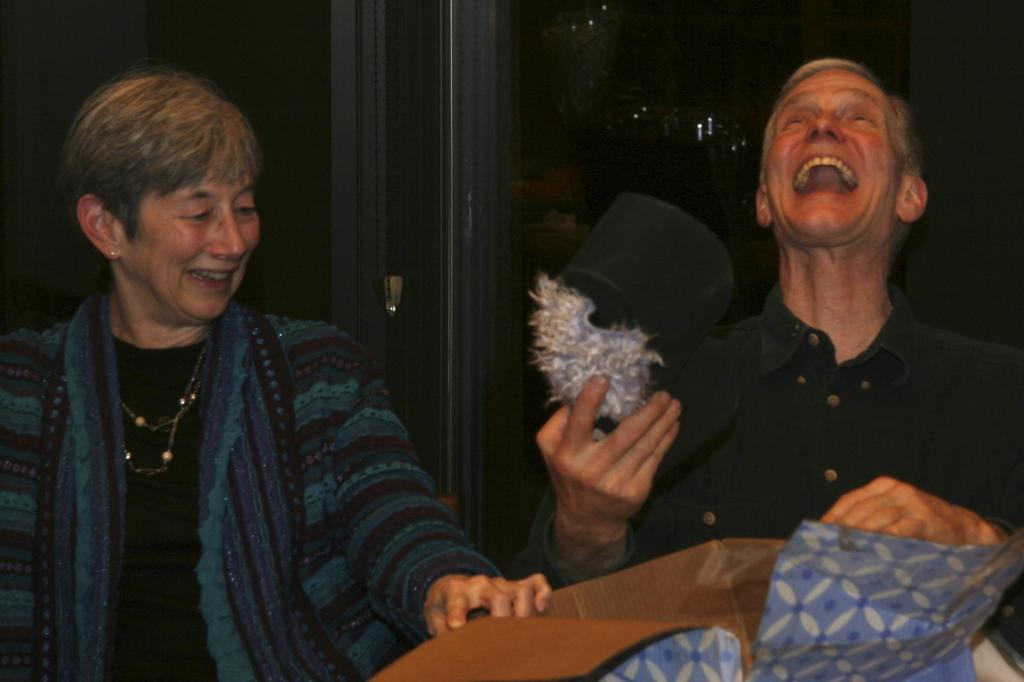Who are the people in the image? There is a man and a woman in the image. What is the man holding in the image? The man is holding an object. How is the man feeling in the image? The man is laughing in the image. What can be observed about the lighting in the image? The background of the image is dark. What type of boat can be seen in the image? There is no boat present in the image. How does the yoke affect the man's actions in the image? There is no yoke present in the image, so it cannot affect the man's actions. 